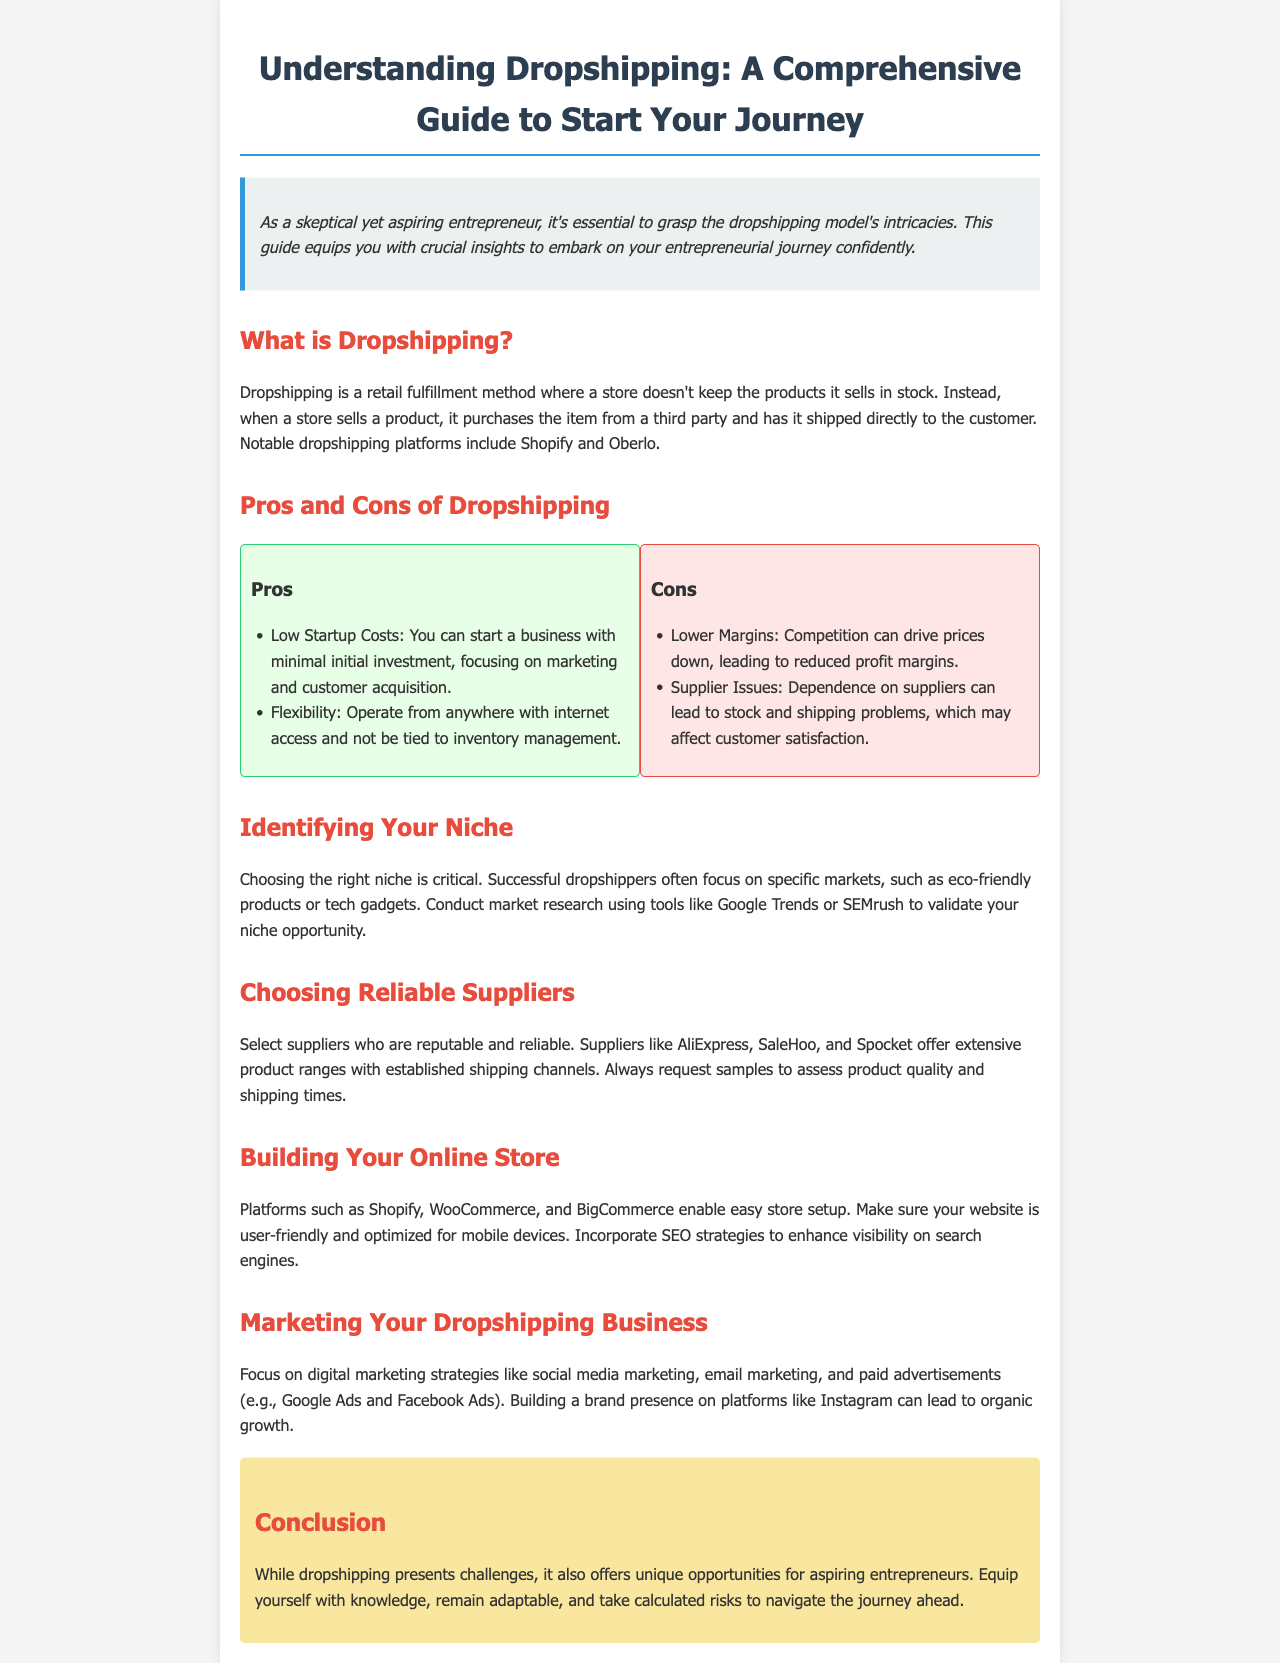What is dropshipping? Dropshipping is defined as a retail fulfillment method where a store doesn't keep the products it sells in stock.
Answer: A retail fulfillment method What are two notable dropshipping platforms mentioned? The document lists notable dropshipping platforms within the context of its definition of dropshipping.
Answer: Shopify and Oberlo What is one pro of dropshipping? The document highlights various advantages of dropshipping, including starting costs and flexibility.
Answer: Low Startup Costs Name one con of dropshipping. The document lists disadvantages associated with dropshipping, emphasizing competition and supplier dependencies.
Answer: Lower Margins What is a crucial factor when identifying your niche? The importance of choosing the right niche is stressed, alongside the significance of market research tools.
Answer: Market research Which platforms can be used to build an online store? The document mentions specific platforms that facilitate setting up an online store.
Answer: Shopify, WooCommerce, BigCommerce What marketing strategy is recommended for a dropshipping business? Several digital marketing strategies are recommended, focusing on social media and other advertisement forms.
Answer: Social media marketing What should you assess before selecting a supplier? The document advises evaluating supplier reputation and testing product quality before making a selection.
Answer: Product quality What does the conclusion suggest for aspiring entrepreneurs? The conclusion emphasizes the importance of knowledge and adaptability for success in dropshipping.
Answer: Equip yourself with knowledge 